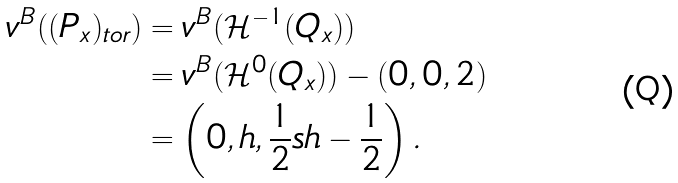<formula> <loc_0><loc_0><loc_500><loc_500>v ^ { B } ( ( P _ { x } ) _ { t o r } ) & = v ^ { B } ( \mathcal { H } ^ { - 1 } ( Q _ { x } ) ) \\ & = v ^ { B } ( \mathcal { H } ^ { 0 } ( Q _ { x } ) ) - ( 0 , 0 , 2 ) \\ & = \left ( 0 , h , \frac { 1 } { 2 } s h - \frac { 1 } { 2 } \right ) .</formula> 